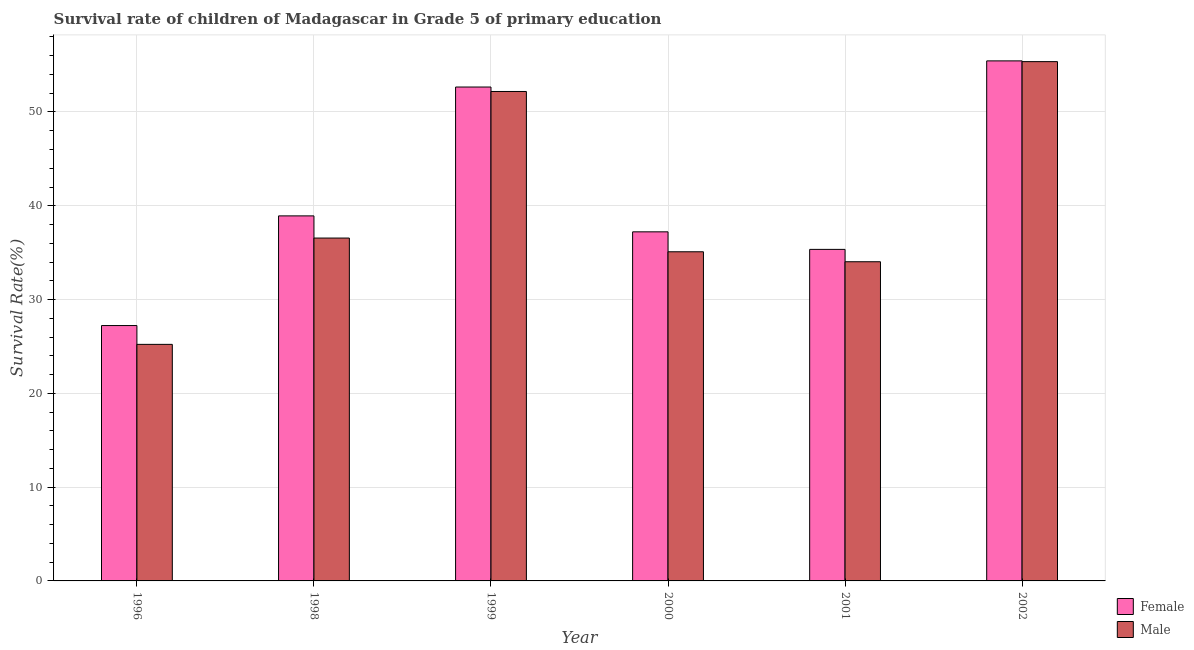How many groups of bars are there?
Your answer should be compact. 6. Are the number of bars per tick equal to the number of legend labels?
Offer a very short reply. Yes. Are the number of bars on each tick of the X-axis equal?
Offer a terse response. Yes. How many bars are there on the 3rd tick from the left?
Provide a short and direct response. 2. What is the label of the 5th group of bars from the left?
Your answer should be compact. 2001. In how many cases, is the number of bars for a given year not equal to the number of legend labels?
Make the answer very short. 0. What is the survival rate of female students in primary education in 1999?
Offer a very short reply. 52.66. Across all years, what is the maximum survival rate of male students in primary education?
Offer a very short reply. 55.37. Across all years, what is the minimum survival rate of female students in primary education?
Offer a very short reply. 27.23. In which year was the survival rate of female students in primary education minimum?
Give a very brief answer. 1996. What is the total survival rate of female students in primary education in the graph?
Your answer should be very brief. 246.83. What is the difference between the survival rate of female students in primary education in 1999 and that in 2002?
Offer a very short reply. -2.79. What is the difference between the survival rate of female students in primary education in 1998 and the survival rate of male students in primary education in 2000?
Your answer should be compact. 1.7. What is the average survival rate of female students in primary education per year?
Provide a succinct answer. 41.14. What is the ratio of the survival rate of male students in primary education in 1998 to that in 2001?
Offer a terse response. 1.07. Is the difference between the survival rate of female students in primary education in 1998 and 1999 greater than the difference between the survival rate of male students in primary education in 1998 and 1999?
Your answer should be compact. No. What is the difference between the highest and the second highest survival rate of female students in primary education?
Give a very brief answer. 2.79. What is the difference between the highest and the lowest survival rate of female students in primary education?
Your answer should be very brief. 28.22. Is the sum of the survival rate of male students in primary education in 1996 and 1999 greater than the maximum survival rate of female students in primary education across all years?
Make the answer very short. Yes. How many bars are there?
Keep it short and to the point. 12. Are all the bars in the graph horizontal?
Your answer should be compact. No. How many years are there in the graph?
Make the answer very short. 6. Does the graph contain any zero values?
Keep it short and to the point. No. Does the graph contain grids?
Ensure brevity in your answer.  Yes. What is the title of the graph?
Make the answer very short. Survival rate of children of Madagascar in Grade 5 of primary education. What is the label or title of the Y-axis?
Your answer should be very brief. Survival Rate(%). What is the Survival Rate(%) in Female in 1996?
Ensure brevity in your answer.  27.23. What is the Survival Rate(%) of Male in 1996?
Ensure brevity in your answer.  25.22. What is the Survival Rate(%) in Female in 1998?
Your response must be concise. 38.92. What is the Survival Rate(%) in Male in 1998?
Offer a very short reply. 36.56. What is the Survival Rate(%) of Female in 1999?
Your answer should be compact. 52.66. What is the Survival Rate(%) of Male in 1999?
Offer a very short reply. 52.19. What is the Survival Rate(%) of Female in 2000?
Make the answer very short. 37.22. What is the Survival Rate(%) in Male in 2000?
Keep it short and to the point. 35.09. What is the Survival Rate(%) in Female in 2001?
Ensure brevity in your answer.  35.35. What is the Survival Rate(%) of Male in 2001?
Your answer should be compact. 34.03. What is the Survival Rate(%) of Female in 2002?
Keep it short and to the point. 55.45. What is the Survival Rate(%) of Male in 2002?
Make the answer very short. 55.37. Across all years, what is the maximum Survival Rate(%) of Female?
Keep it short and to the point. 55.45. Across all years, what is the maximum Survival Rate(%) of Male?
Your answer should be very brief. 55.37. Across all years, what is the minimum Survival Rate(%) in Female?
Offer a terse response. 27.23. Across all years, what is the minimum Survival Rate(%) in Male?
Offer a very short reply. 25.22. What is the total Survival Rate(%) of Female in the graph?
Ensure brevity in your answer.  246.83. What is the total Survival Rate(%) in Male in the graph?
Offer a very short reply. 238.46. What is the difference between the Survival Rate(%) in Female in 1996 and that in 1998?
Give a very brief answer. -11.69. What is the difference between the Survival Rate(%) of Male in 1996 and that in 1998?
Make the answer very short. -11.34. What is the difference between the Survival Rate(%) in Female in 1996 and that in 1999?
Give a very brief answer. -25.43. What is the difference between the Survival Rate(%) in Male in 1996 and that in 1999?
Make the answer very short. -26.96. What is the difference between the Survival Rate(%) of Female in 1996 and that in 2000?
Offer a terse response. -9.99. What is the difference between the Survival Rate(%) of Male in 1996 and that in 2000?
Offer a very short reply. -9.87. What is the difference between the Survival Rate(%) in Female in 1996 and that in 2001?
Ensure brevity in your answer.  -8.12. What is the difference between the Survival Rate(%) in Male in 1996 and that in 2001?
Make the answer very short. -8.81. What is the difference between the Survival Rate(%) in Female in 1996 and that in 2002?
Ensure brevity in your answer.  -28.22. What is the difference between the Survival Rate(%) of Male in 1996 and that in 2002?
Provide a succinct answer. -30.15. What is the difference between the Survival Rate(%) of Female in 1998 and that in 1999?
Offer a very short reply. -13.74. What is the difference between the Survival Rate(%) in Male in 1998 and that in 1999?
Make the answer very short. -15.63. What is the difference between the Survival Rate(%) of Female in 1998 and that in 2000?
Your answer should be very brief. 1.7. What is the difference between the Survival Rate(%) in Male in 1998 and that in 2000?
Your response must be concise. 1.46. What is the difference between the Survival Rate(%) in Female in 1998 and that in 2001?
Ensure brevity in your answer.  3.57. What is the difference between the Survival Rate(%) in Male in 1998 and that in 2001?
Keep it short and to the point. 2.53. What is the difference between the Survival Rate(%) of Female in 1998 and that in 2002?
Ensure brevity in your answer.  -16.53. What is the difference between the Survival Rate(%) of Male in 1998 and that in 2002?
Your answer should be compact. -18.81. What is the difference between the Survival Rate(%) of Female in 1999 and that in 2000?
Make the answer very short. 15.44. What is the difference between the Survival Rate(%) of Male in 1999 and that in 2000?
Your answer should be compact. 17.09. What is the difference between the Survival Rate(%) in Female in 1999 and that in 2001?
Keep it short and to the point. 17.31. What is the difference between the Survival Rate(%) of Male in 1999 and that in 2001?
Provide a short and direct response. 18.16. What is the difference between the Survival Rate(%) of Female in 1999 and that in 2002?
Offer a terse response. -2.79. What is the difference between the Survival Rate(%) in Male in 1999 and that in 2002?
Make the answer very short. -3.18. What is the difference between the Survival Rate(%) of Female in 2000 and that in 2001?
Your answer should be very brief. 1.87. What is the difference between the Survival Rate(%) of Male in 2000 and that in 2001?
Your answer should be compact. 1.06. What is the difference between the Survival Rate(%) in Female in 2000 and that in 2002?
Keep it short and to the point. -18.23. What is the difference between the Survival Rate(%) in Male in 2000 and that in 2002?
Give a very brief answer. -20.27. What is the difference between the Survival Rate(%) of Female in 2001 and that in 2002?
Your response must be concise. -20.1. What is the difference between the Survival Rate(%) of Male in 2001 and that in 2002?
Provide a short and direct response. -21.34. What is the difference between the Survival Rate(%) of Female in 1996 and the Survival Rate(%) of Male in 1998?
Give a very brief answer. -9.33. What is the difference between the Survival Rate(%) of Female in 1996 and the Survival Rate(%) of Male in 1999?
Your answer should be compact. -24.96. What is the difference between the Survival Rate(%) of Female in 1996 and the Survival Rate(%) of Male in 2000?
Your answer should be very brief. -7.87. What is the difference between the Survival Rate(%) in Female in 1996 and the Survival Rate(%) in Male in 2001?
Your response must be concise. -6.8. What is the difference between the Survival Rate(%) in Female in 1996 and the Survival Rate(%) in Male in 2002?
Keep it short and to the point. -28.14. What is the difference between the Survival Rate(%) of Female in 1998 and the Survival Rate(%) of Male in 1999?
Provide a succinct answer. -13.27. What is the difference between the Survival Rate(%) in Female in 1998 and the Survival Rate(%) in Male in 2000?
Ensure brevity in your answer.  3.83. What is the difference between the Survival Rate(%) in Female in 1998 and the Survival Rate(%) in Male in 2001?
Your response must be concise. 4.89. What is the difference between the Survival Rate(%) of Female in 1998 and the Survival Rate(%) of Male in 2002?
Your answer should be compact. -16.45. What is the difference between the Survival Rate(%) in Female in 1999 and the Survival Rate(%) in Male in 2000?
Give a very brief answer. 17.57. What is the difference between the Survival Rate(%) of Female in 1999 and the Survival Rate(%) of Male in 2001?
Ensure brevity in your answer.  18.63. What is the difference between the Survival Rate(%) in Female in 1999 and the Survival Rate(%) in Male in 2002?
Make the answer very short. -2.71. What is the difference between the Survival Rate(%) of Female in 2000 and the Survival Rate(%) of Male in 2001?
Give a very brief answer. 3.19. What is the difference between the Survival Rate(%) in Female in 2000 and the Survival Rate(%) in Male in 2002?
Provide a short and direct response. -18.15. What is the difference between the Survival Rate(%) of Female in 2001 and the Survival Rate(%) of Male in 2002?
Your answer should be compact. -20.02. What is the average Survival Rate(%) in Female per year?
Offer a very short reply. 41.14. What is the average Survival Rate(%) in Male per year?
Provide a succinct answer. 39.74. In the year 1996, what is the difference between the Survival Rate(%) in Female and Survival Rate(%) in Male?
Give a very brief answer. 2.01. In the year 1998, what is the difference between the Survival Rate(%) of Female and Survival Rate(%) of Male?
Your response must be concise. 2.36. In the year 1999, what is the difference between the Survival Rate(%) of Female and Survival Rate(%) of Male?
Your answer should be very brief. 0.47. In the year 2000, what is the difference between the Survival Rate(%) of Female and Survival Rate(%) of Male?
Your answer should be very brief. 2.13. In the year 2001, what is the difference between the Survival Rate(%) of Female and Survival Rate(%) of Male?
Offer a terse response. 1.32. In the year 2002, what is the difference between the Survival Rate(%) of Female and Survival Rate(%) of Male?
Ensure brevity in your answer.  0.08. What is the ratio of the Survival Rate(%) of Female in 1996 to that in 1998?
Keep it short and to the point. 0.7. What is the ratio of the Survival Rate(%) in Male in 1996 to that in 1998?
Your answer should be compact. 0.69. What is the ratio of the Survival Rate(%) of Female in 1996 to that in 1999?
Your response must be concise. 0.52. What is the ratio of the Survival Rate(%) in Male in 1996 to that in 1999?
Your answer should be compact. 0.48. What is the ratio of the Survival Rate(%) of Female in 1996 to that in 2000?
Your answer should be very brief. 0.73. What is the ratio of the Survival Rate(%) in Male in 1996 to that in 2000?
Offer a very short reply. 0.72. What is the ratio of the Survival Rate(%) in Female in 1996 to that in 2001?
Provide a succinct answer. 0.77. What is the ratio of the Survival Rate(%) in Male in 1996 to that in 2001?
Offer a very short reply. 0.74. What is the ratio of the Survival Rate(%) in Female in 1996 to that in 2002?
Your answer should be very brief. 0.49. What is the ratio of the Survival Rate(%) of Male in 1996 to that in 2002?
Provide a succinct answer. 0.46. What is the ratio of the Survival Rate(%) in Female in 1998 to that in 1999?
Provide a succinct answer. 0.74. What is the ratio of the Survival Rate(%) of Male in 1998 to that in 1999?
Provide a succinct answer. 0.7. What is the ratio of the Survival Rate(%) of Female in 1998 to that in 2000?
Give a very brief answer. 1.05. What is the ratio of the Survival Rate(%) in Male in 1998 to that in 2000?
Make the answer very short. 1.04. What is the ratio of the Survival Rate(%) in Female in 1998 to that in 2001?
Provide a succinct answer. 1.1. What is the ratio of the Survival Rate(%) in Male in 1998 to that in 2001?
Your response must be concise. 1.07. What is the ratio of the Survival Rate(%) in Female in 1998 to that in 2002?
Make the answer very short. 0.7. What is the ratio of the Survival Rate(%) in Male in 1998 to that in 2002?
Ensure brevity in your answer.  0.66. What is the ratio of the Survival Rate(%) in Female in 1999 to that in 2000?
Offer a very short reply. 1.41. What is the ratio of the Survival Rate(%) of Male in 1999 to that in 2000?
Your answer should be very brief. 1.49. What is the ratio of the Survival Rate(%) in Female in 1999 to that in 2001?
Your answer should be very brief. 1.49. What is the ratio of the Survival Rate(%) of Male in 1999 to that in 2001?
Provide a short and direct response. 1.53. What is the ratio of the Survival Rate(%) of Female in 1999 to that in 2002?
Your response must be concise. 0.95. What is the ratio of the Survival Rate(%) in Male in 1999 to that in 2002?
Make the answer very short. 0.94. What is the ratio of the Survival Rate(%) of Female in 2000 to that in 2001?
Keep it short and to the point. 1.05. What is the ratio of the Survival Rate(%) in Male in 2000 to that in 2001?
Give a very brief answer. 1.03. What is the ratio of the Survival Rate(%) of Female in 2000 to that in 2002?
Offer a very short reply. 0.67. What is the ratio of the Survival Rate(%) in Male in 2000 to that in 2002?
Provide a short and direct response. 0.63. What is the ratio of the Survival Rate(%) of Female in 2001 to that in 2002?
Offer a terse response. 0.64. What is the ratio of the Survival Rate(%) in Male in 2001 to that in 2002?
Ensure brevity in your answer.  0.61. What is the difference between the highest and the second highest Survival Rate(%) in Female?
Ensure brevity in your answer.  2.79. What is the difference between the highest and the second highest Survival Rate(%) in Male?
Your answer should be very brief. 3.18. What is the difference between the highest and the lowest Survival Rate(%) in Female?
Ensure brevity in your answer.  28.22. What is the difference between the highest and the lowest Survival Rate(%) of Male?
Make the answer very short. 30.15. 